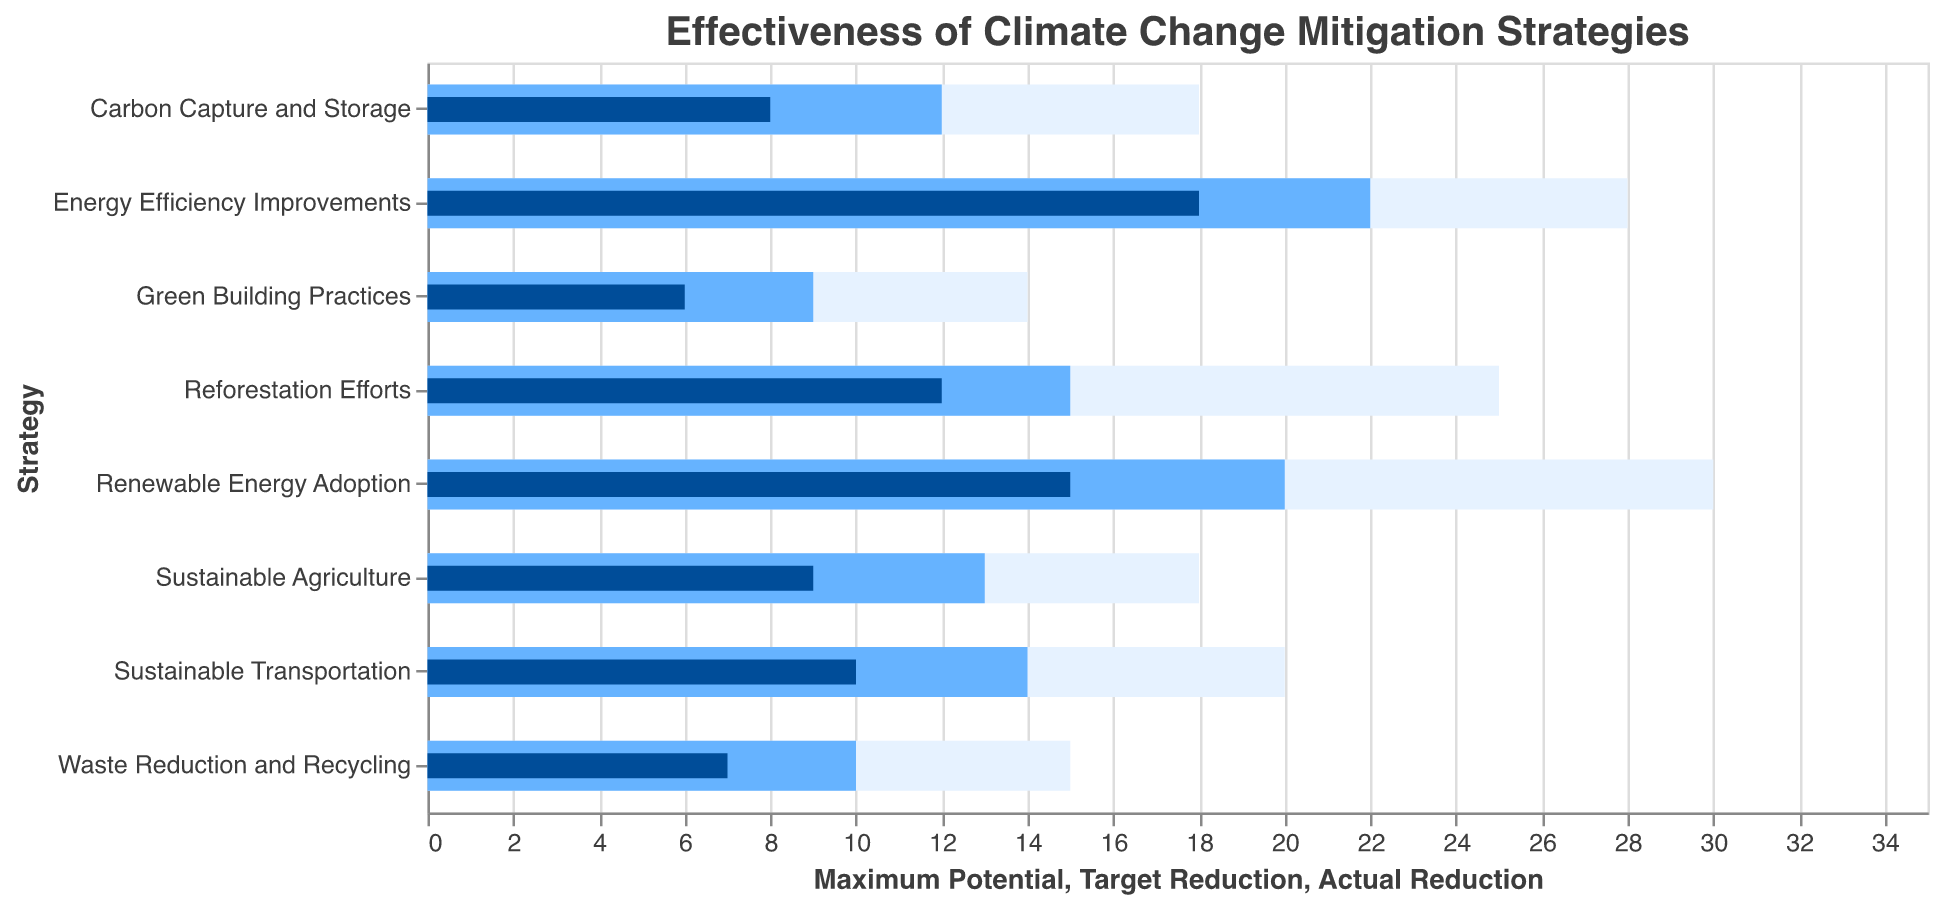What is the title of the figure? The title of the figure can be found at the top and it states the main topic of the chart, which in this instance refers to the effectiveness of different climate change mitigation strategies.
Answer: Effectiveness of Climate Change Mitigation Strategies Which strategy shows the highest actual reduction? To find the strategy with the highest actual reduction, compare the actual reduction values of all the strategies. The strategy with the maximum value is Energy Efficiency Improvements with an actual reduction of 18.
Answer: Energy Efficiency Improvements What is the actual reduction value of Reforestation Efforts? The actual reduction value of Reforestation Efforts can be read directly from the corresponding bar. The value is 12.
Answer: 12 How many strategies have an actual reduction greater than 10? Identify all the strategies whose actual reduction bars are greater than 10 units. These strategies are Renewable Energy Adoption, Reforestation Efforts, Energy Efficiency Improvements, and Sustainable Transportation, totaling 4.
Answer: 4 What is the difference between the target reduction and actual reduction for Sustainable Agriculture? The target reduction for Sustainable Agriculture is 13 and the actual reduction is 9. The difference is obtained by subtracting the actual from the target, which is 13 - 9 = 4.
Answer: 4 Which strategy has the smallest maximum potential reduction? The smallest maximum potential reduction is found directly from the figure by comparing all the maximum potential bars. Green Building Practices has the smallest value with 14.
Answer: Green Building Practices How much more reduction is targeted for Carbon Capture and Storage compared to Waste Reduction and Recycling? The target reduction for Carbon Capture and Storage is 12, and for Waste Reduction and Recycling, it is 10. The difference is 12 - 10 = 2.
Answer: 2 Are any strategies meeting or exceeding their target reduction? To determine this, compare the actual reduction values to their respective target reductions. None of the strategies' actual reductions meet or exceed their target reductions.
Answer: No Which strategy has the largest gap between maximum potential and actual reduction? Calculate the gap for each strategy by subtracting the actual reduction from the maximum potential. The largest gap is in Renewable Energy Adoption, with a gap of 30 - 15 = 15.
Answer: Renewable Energy Adoption Which strategies have an actual reduction that is half or more of their maximum potential? Compare the actual reductions to half of the respective maximum potential values. Strategies meeting this criterion are Renewable Energy Adoption, Reforestation Efforts, Energy Efficiency Improvements, and Sustainable Transportation.
Answer: Renewable Energy Adoption, Reforestation Efforts, Energy Efficiency Improvements, Sustainable Transportation 